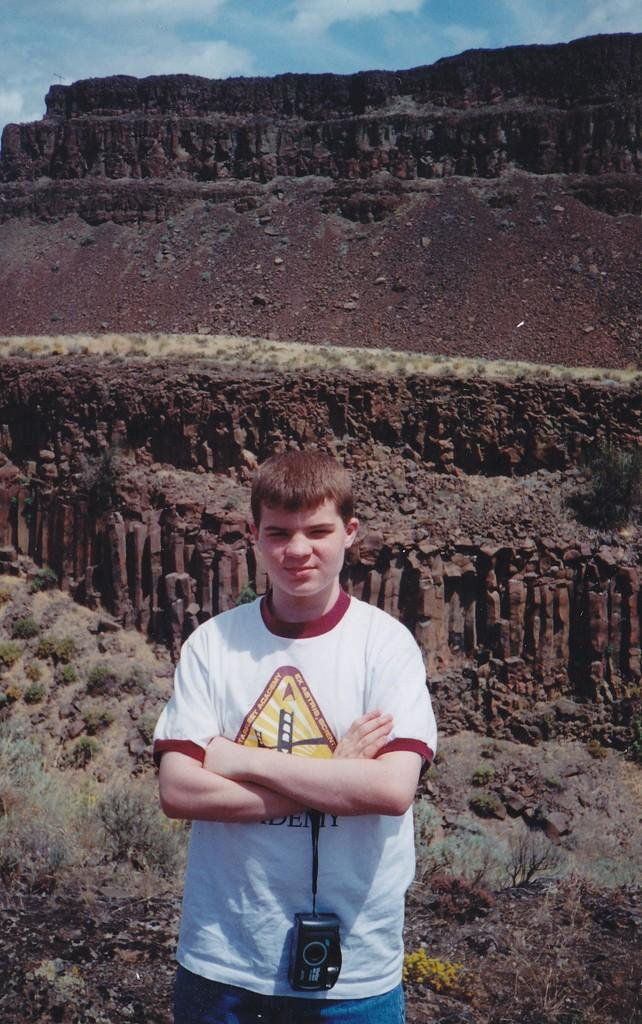What is the main subject of the image? The main subject of the image is a kid. What is the kid wearing in the image? The kid is wearing a white T-shirt in the image. What is the kid holding in the image? The kid is carrying a camera in the image. What can be seen in the background of the image? There are mountains visible in the background of the image. What type of stem can be seen growing in the image? There is no stem present in the image; it features a kid wearing a white T-shirt and carrying a camera, with mountains in the background. 